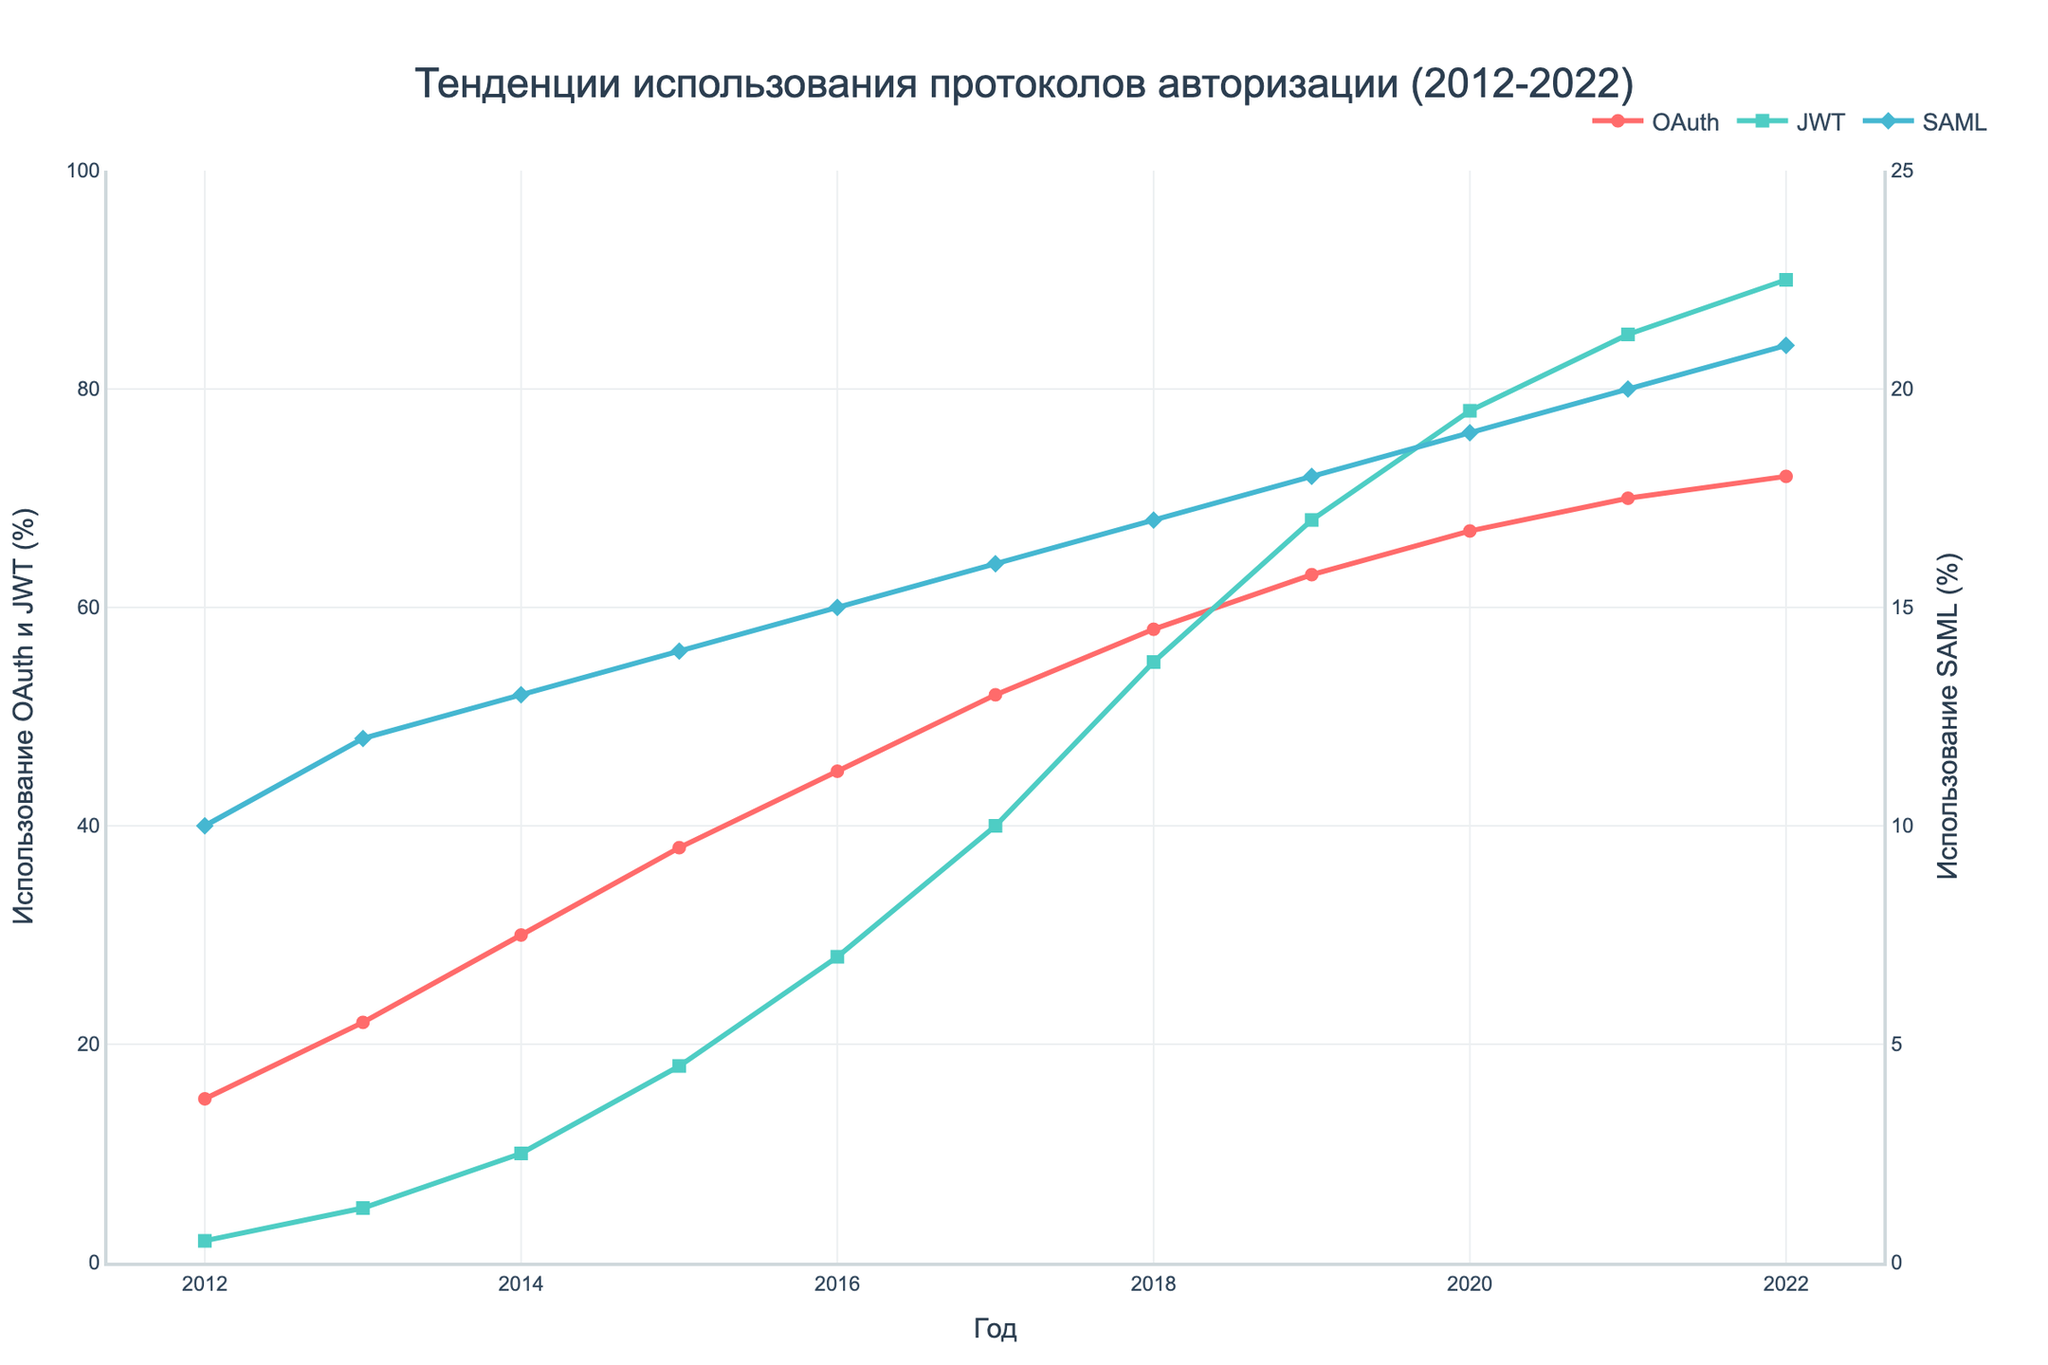Какой протокол авторизации достиг наибольшего уровня использования в 2022 году? Посмотрите на окончательные точки линий трех протоколов. Видно, что JWT имеет наибольшее значение среди всех трех протоколов в 2022 году.
Answer: JWT Как изменилось использование OAuth с 2012 по 2022 год? Посмотрите на график линии OAuth и определите начальную точку в 2012 году (15%) и конечную точку в 2022 году (72%). Разность этих значений покажет изменение. (72 - 15 = 57)
Answer: Увеличение на 57% Какое минимальное значение использования было у протокола JWT за все годы? Посмотрите на линию JWT и определите наименьшее значение за все годы. Это значение было в 2012 году (2%).
Answer: 2% Как изменилось использование SAML с 2015 по 2020 год? Найдите значения для SAML в 2015 (14%) и в 2020 (19%). Определите разницу между этими значениями (19 - 14 = 5).
Answer: Увеличение на 5% Сравните использование OAuth и JWT в 2017 году. Какой протокол использовался больше и на сколько процентов? Посмотрите на значения для 2017 года: OAuth - 52%, JWT - 40%. Сравнив эти значения, определите разницу (52 - 40 = 12), OAuth используется больше на 12%.
Answer: OAuth использовался больше на 12% Какова была средняя доля использования SAML за последние пять лет (2018-2022)? Найдите значения использования SAML с 2018 по 2022 годы (17%, 18%, 19%, 20%, 21%), сложите их (17 + 18 + 19 + 20 + 21 = 95) и разделите на количество лет (95 / 5 = 19).
Answer: 19% Какой протокол показал наименьший рост с 2012 по 2022 год? Посмотрите на конечные и начальные значения для всех трех протоколов. Начальные значения: OAuth - 15%, JWT - 2%, SAML - 10%; конечные значения: OAuth - 72%, JWT - 90%, SAML - 21%. Определите прирост для каждого протокола: OAuth - 57, JWT - 88, SAML - 11. SAML имеет наименьший рост.
Answer: SAML Как изменился разрыв в использовании между OAuth и JWT с 2015 по 2022 год? Найдите разницу в использовании между OAuth и JWT в 2015 (OAuth - 38%, JWT - 18%, разница 20%) и в 2022 (OAuth - 72%, JWT - 90%, разница -18%). Рассчитайте изменение разницы в процентах (20 - (-18) = 38%).
Answer: Уменьшился на 38% 